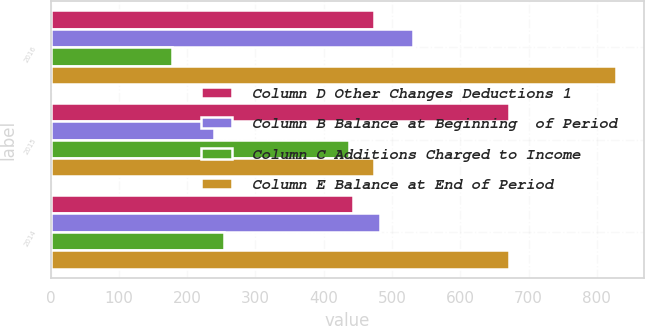Convert chart to OTSL. <chart><loc_0><loc_0><loc_500><loc_500><stacked_bar_chart><ecel><fcel>2016<fcel>2015<fcel>2014<nl><fcel>Column D Other Changes Deductions 1<fcel>474<fcel>672<fcel>443<nl><fcel>Column B Balance at Beginning  of Period<fcel>531<fcel>239<fcel>483<nl><fcel>Column C Additions Charged to Income<fcel>177<fcel>437<fcel>254<nl><fcel>Column E Balance at End of Period<fcel>828<fcel>474<fcel>672<nl></chart> 